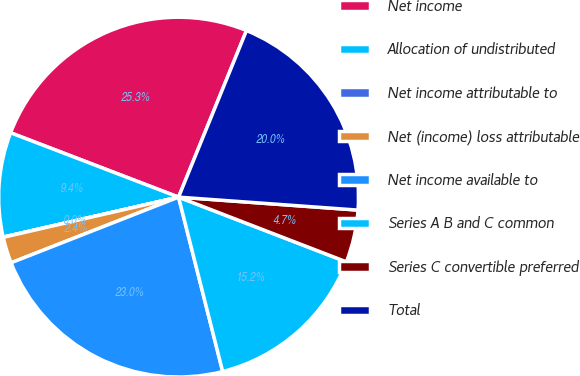Convert chart. <chart><loc_0><loc_0><loc_500><loc_500><pie_chart><fcel>Net income<fcel>Allocation of undistributed<fcel>Net income attributable to<fcel>Net (income) loss attributable<fcel>Net income available to<fcel>Series A B and C common<fcel>Series C convertible preferred<fcel>Total<nl><fcel>25.34%<fcel>9.39%<fcel>0.02%<fcel>2.36%<fcel>23.0%<fcel>15.2%<fcel>4.71%<fcel>19.99%<nl></chart> 